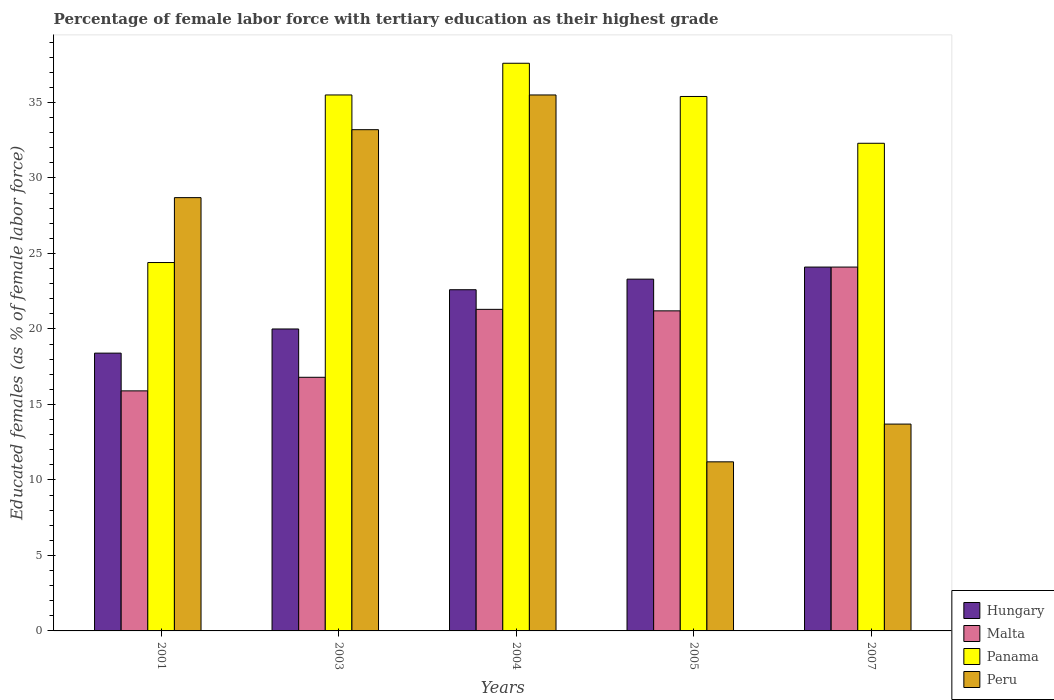How many different coloured bars are there?
Offer a very short reply. 4. How many bars are there on the 4th tick from the left?
Make the answer very short. 4. How many bars are there on the 3rd tick from the right?
Provide a succinct answer. 4. What is the label of the 2nd group of bars from the left?
Your answer should be very brief. 2003. In how many cases, is the number of bars for a given year not equal to the number of legend labels?
Offer a very short reply. 0. What is the percentage of female labor force with tertiary education in Malta in 2003?
Ensure brevity in your answer.  16.8. Across all years, what is the maximum percentage of female labor force with tertiary education in Hungary?
Make the answer very short. 24.1. Across all years, what is the minimum percentage of female labor force with tertiary education in Panama?
Ensure brevity in your answer.  24.4. In which year was the percentage of female labor force with tertiary education in Hungary minimum?
Provide a short and direct response. 2001. What is the total percentage of female labor force with tertiary education in Peru in the graph?
Your answer should be compact. 122.3. What is the difference between the percentage of female labor force with tertiary education in Hungary in 2004 and that in 2005?
Provide a succinct answer. -0.7. What is the difference between the percentage of female labor force with tertiary education in Peru in 2003 and the percentage of female labor force with tertiary education in Malta in 2001?
Keep it short and to the point. 17.3. What is the average percentage of female labor force with tertiary education in Peru per year?
Make the answer very short. 24.46. In the year 2004, what is the difference between the percentage of female labor force with tertiary education in Peru and percentage of female labor force with tertiary education in Malta?
Provide a short and direct response. 14.2. In how many years, is the percentage of female labor force with tertiary education in Peru greater than 20 %?
Give a very brief answer. 3. What is the ratio of the percentage of female labor force with tertiary education in Peru in 2003 to that in 2004?
Your response must be concise. 0.94. Is the percentage of female labor force with tertiary education in Malta in 2001 less than that in 2005?
Provide a succinct answer. Yes. Is the difference between the percentage of female labor force with tertiary education in Peru in 2003 and 2007 greater than the difference between the percentage of female labor force with tertiary education in Malta in 2003 and 2007?
Make the answer very short. Yes. What is the difference between the highest and the second highest percentage of female labor force with tertiary education in Panama?
Offer a terse response. 2.1. What is the difference between the highest and the lowest percentage of female labor force with tertiary education in Panama?
Your response must be concise. 13.2. In how many years, is the percentage of female labor force with tertiary education in Panama greater than the average percentage of female labor force with tertiary education in Panama taken over all years?
Make the answer very short. 3. Is the sum of the percentage of female labor force with tertiary education in Panama in 2001 and 2005 greater than the maximum percentage of female labor force with tertiary education in Hungary across all years?
Give a very brief answer. Yes. What does the 1st bar from the left in 2001 represents?
Your answer should be compact. Hungary. What does the 4th bar from the right in 2004 represents?
Your answer should be compact. Hungary. How many bars are there?
Offer a terse response. 20. What is the difference between two consecutive major ticks on the Y-axis?
Make the answer very short. 5. How are the legend labels stacked?
Provide a succinct answer. Vertical. What is the title of the graph?
Keep it short and to the point. Percentage of female labor force with tertiary education as their highest grade. What is the label or title of the Y-axis?
Provide a succinct answer. Educated females (as % of female labor force). What is the Educated females (as % of female labor force) of Hungary in 2001?
Offer a terse response. 18.4. What is the Educated females (as % of female labor force) in Malta in 2001?
Your answer should be compact. 15.9. What is the Educated females (as % of female labor force) of Panama in 2001?
Make the answer very short. 24.4. What is the Educated females (as % of female labor force) of Peru in 2001?
Your answer should be very brief. 28.7. What is the Educated females (as % of female labor force) of Malta in 2003?
Ensure brevity in your answer.  16.8. What is the Educated females (as % of female labor force) of Panama in 2003?
Offer a terse response. 35.5. What is the Educated females (as % of female labor force) of Peru in 2003?
Your response must be concise. 33.2. What is the Educated females (as % of female labor force) of Hungary in 2004?
Provide a succinct answer. 22.6. What is the Educated females (as % of female labor force) in Malta in 2004?
Offer a very short reply. 21.3. What is the Educated females (as % of female labor force) of Panama in 2004?
Your answer should be very brief. 37.6. What is the Educated females (as % of female labor force) in Peru in 2004?
Ensure brevity in your answer.  35.5. What is the Educated females (as % of female labor force) of Hungary in 2005?
Offer a terse response. 23.3. What is the Educated females (as % of female labor force) of Malta in 2005?
Provide a short and direct response. 21.2. What is the Educated females (as % of female labor force) of Panama in 2005?
Make the answer very short. 35.4. What is the Educated females (as % of female labor force) in Peru in 2005?
Your response must be concise. 11.2. What is the Educated females (as % of female labor force) of Hungary in 2007?
Ensure brevity in your answer.  24.1. What is the Educated females (as % of female labor force) in Malta in 2007?
Your answer should be compact. 24.1. What is the Educated females (as % of female labor force) of Panama in 2007?
Offer a terse response. 32.3. What is the Educated females (as % of female labor force) of Peru in 2007?
Provide a short and direct response. 13.7. Across all years, what is the maximum Educated females (as % of female labor force) of Hungary?
Your answer should be compact. 24.1. Across all years, what is the maximum Educated females (as % of female labor force) in Malta?
Ensure brevity in your answer.  24.1. Across all years, what is the maximum Educated females (as % of female labor force) in Panama?
Your response must be concise. 37.6. Across all years, what is the maximum Educated females (as % of female labor force) of Peru?
Your answer should be compact. 35.5. Across all years, what is the minimum Educated females (as % of female labor force) in Hungary?
Provide a succinct answer. 18.4. Across all years, what is the minimum Educated females (as % of female labor force) of Malta?
Your response must be concise. 15.9. Across all years, what is the minimum Educated females (as % of female labor force) in Panama?
Offer a very short reply. 24.4. Across all years, what is the minimum Educated females (as % of female labor force) in Peru?
Ensure brevity in your answer.  11.2. What is the total Educated females (as % of female labor force) in Hungary in the graph?
Make the answer very short. 108.4. What is the total Educated females (as % of female labor force) of Malta in the graph?
Keep it short and to the point. 99.3. What is the total Educated females (as % of female labor force) in Panama in the graph?
Your response must be concise. 165.2. What is the total Educated females (as % of female labor force) in Peru in the graph?
Keep it short and to the point. 122.3. What is the difference between the Educated females (as % of female labor force) of Hungary in 2001 and that in 2003?
Make the answer very short. -1.6. What is the difference between the Educated females (as % of female labor force) in Peru in 2001 and that in 2003?
Your answer should be very brief. -4.5. What is the difference between the Educated females (as % of female labor force) of Hungary in 2001 and that in 2004?
Offer a terse response. -4.2. What is the difference between the Educated females (as % of female labor force) in Panama in 2001 and that in 2004?
Your answer should be very brief. -13.2. What is the difference between the Educated females (as % of female labor force) in Hungary in 2001 and that in 2005?
Make the answer very short. -4.9. What is the difference between the Educated females (as % of female labor force) in Malta in 2001 and that in 2005?
Your response must be concise. -5.3. What is the difference between the Educated females (as % of female labor force) of Hungary in 2003 and that in 2004?
Provide a succinct answer. -2.6. What is the difference between the Educated females (as % of female labor force) of Malta in 2003 and that in 2004?
Make the answer very short. -4.5. What is the difference between the Educated females (as % of female labor force) of Panama in 2003 and that in 2004?
Offer a terse response. -2.1. What is the difference between the Educated females (as % of female labor force) of Hungary in 2003 and that in 2007?
Give a very brief answer. -4.1. What is the difference between the Educated females (as % of female labor force) in Malta in 2003 and that in 2007?
Provide a succinct answer. -7.3. What is the difference between the Educated females (as % of female labor force) of Panama in 2003 and that in 2007?
Offer a very short reply. 3.2. What is the difference between the Educated females (as % of female labor force) of Hungary in 2004 and that in 2005?
Keep it short and to the point. -0.7. What is the difference between the Educated females (as % of female labor force) in Peru in 2004 and that in 2005?
Your answer should be very brief. 24.3. What is the difference between the Educated females (as % of female labor force) of Peru in 2004 and that in 2007?
Ensure brevity in your answer.  21.8. What is the difference between the Educated females (as % of female labor force) of Hungary in 2005 and that in 2007?
Offer a terse response. -0.8. What is the difference between the Educated females (as % of female labor force) in Peru in 2005 and that in 2007?
Provide a succinct answer. -2.5. What is the difference between the Educated females (as % of female labor force) of Hungary in 2001 and the Educated females (as % of female labor force) of Panama in 2003?
Give a very brief answer. -17.1. What is the difference between the Educated females (as % of female labor force) in Hungary in 2001 and the Educated females (as % of female labor force) in Peru in 2003?
Your answer should be compact. -14.8. What is the difference between the Educated females (as % of female labor force) in Malta in 2001 and the Educated females (as % of female labor force) in Panama in 2003?
Ensure brevity in your answer.  -19.6. What is the difference between the Educated females (as % of female labor force) in Malta in 2001 and the Educated females (as % of female labor force) in Peru in 2003?
Your response must be concise. -17.3. What is the difference between the Educated females (as % of female labor force) of Hungary in 2001 and the Educated females (as % of female labor force) of Malta in 2004?
Ensure brevity in your answer.  -2.9. What is the difference between the Educated females (as % of female labor force) of Hungary in 2001 and the Educated females (as % of female labor force) of Panama in 2004?
Your response must be concise. -19.2. What is the difference between the Educated females (as % of female labor force) in Hungary in 2001 and the Educated females (as % of female labor force) in Peru in 2004?
Your answer should be compact. -17.1. What is the difference between the Educated females (as % of female labor force) in Malta in 2001 and the Educated females (as % of female labor force) in Panama in 2004?
Provide a short and direct response. -21.7. What is the difference between the Educated females (as % of female labor force) in Malta in 2001 and the Educated females (as % of female labor force) in Peru in 2004?
Provide a short and direct response. -19.6. What is the difference between the Educated females (as % of female labor force) of Hungary in 2001 and the Educated females (as % of female labor force) of Malta in 2005?
Provide a succinct answer. -2.8. What is the difference between the Educated females (as % of female labor force) of Hungary in 2001 and the Educated females (as % of female labor force) of Peru in 2005?
Offer a very short reply. 7.2. What is the difference between the Educated females (as % of female labor force) in Malta in 2001 and the Educated females (as % of female labor force) in Panama in 2005?
Your response must be concise. -19.5. What is the difference between the Educated females (as % of female labor force) of Malta in 2001 and the Educated females (as % of female labor force) of Peru in 2005?
Your response must be concise. 4.7. What is the difference between the Educated females (as % of female labor force) in Malta in 2001 and the Educated females (as % of female labor force) in Panama in 2007?
Make the answer very short. -16.4. What is the difference between the Educated females (as % of female labor force) in Panama in 2001 and the Educated females (as % of female labor force) in Peru in 2007?
Provide a short and direct response. 10.7. What is the difference between the Educated females (as % of female labor force) of Hungary in 2003 and the Educated females (as % of female labor force) of Panama in 2004?
Keep it short and to the point. -17.6. What is the difference between the Educated females (as % of female labor force) in Hungary in 2003 and the Educated females (as % of female labor force) in Peru in 2004?
Your response must be concise. -15.5. What is the difference between the Educated females (as % of female labor force) of Malta in 2003 and the Educated females (as % of female labor force) of Panama in 2004?
Ensure brevity in your answer.  -20.8. What is the difference between the Educated females (as % of female labor force) of Malta in 2003 and the Educated females (as % of female labor force) of Peru in 2004?
Your response must be concise. -18.7. What is the difference between the Educated females (as % of female labor force) of Panama in 2003 and the Educated females (as % of female labor force) of Peru in 2004?
Offer a very short reply. 0. What is the difference between the Educated females (as % of female labor force) in Hungary in 2003 and the Educated females (as % of female labor force) in Panama in 2005?
Your answer should be compact. -15.4. What is the difference between the Educated females (as % of female labor force) in Hungary in 2003 and the Educated females (as % of female labor force) in Peru in 2005?
Keep it short and to the point. 8.8. What is the difference between the Educated females (as % of female labor force) in Malta in 2003 and the Educated females (as % of female labor force) in Panama in 2005?
Provide a short and direct response. -18.6. What is the difference between the Educated females (as % of female labor force) of Panama in 2003 and the Educated females (as % of female labor force) of Peru in 2005?
Provide a succinct answer. 24.3. What is the difference between the Educated females (as % of female labor force) of Hungary in 2003 and the Educated females (as % of female labor force) of Malta in 2007?
Ensure brevity in your answer.  -4.1. What is the difference between the Educated females (as % of female labor force) of Hungary in 2003 and the Educated females (as % of female labor force) of Panama in 2007?
Offer a terse response. -12.3. What is the difference between the Educated females (as % of female labor force) in Hungary in 2003 and the Educated females (as % of female labor force) in Peru in 2007?
Your answer should be compact. 6.3. What is the difference between the Educated females (as % of female labor force) in Malta in 2003 and the Educated females (as % of female labor force) in Panama in 2007?
Make the answer very short. -15.5. What is the difference between the Educated females (as % of female labor force) in Panama in 2003 and the Educated females (as % of female labor force) in Peru in 2007?
Provide a short and direct response. 21.8. What is the difference between the Educated females (as % of female labor force) of Hungary in 2004 and the Educated females (as % of female labor force) of Malta in 2005?
Your response must be concise. 1.4. What is the difference between the Educated females (as % of female labor force) in Malta in 2004 and the Educated females (as % of female labor force) in Panama in 2005?
Ensure brevity in your answer.  -14.1. What is the difference between the Educated females (as % of female labor force) of Malta in 2004 and the Educated females (as % of female labor force) of Peru in 2005?
Your answer should be compact. 10.1. What is the difference between the Educated females (as % of female labor force) of Panama in 2004 and the Educated females (as % of female labor force) of Peru in 2005?
Provide a succinct answer. 26.4. What is the difference between the Educated females (as % of female labor force) of Hungary in 2004 and the Educated females (as % of female labor force) of Peru in 2007?
Your response must be concise. 8.9. What is the difference between the Educated females (as % of female labor force) of Malta in 2004 and the Educated females (as % of female labor force) of Panama in 2007?
Your answer should be very brief. -11. What is the difference between the Educated females (as % of female labor force) in Panama in 2004 and the Educated females (as % of female labor force) in Peru in 2007?
Your response must be concise. 23.9. What is the difference between the Educated females (as % of female labor force) in Hungary in 2005 and the Educated females (as % of female labor force) in Panama in 2007?
Make the answer very short. -9. What is the difference between the Educated females (as % of female labor force) in Hungary in 2005 and the Educated females (as % of female labor force) in Peru in 2007?
Your response must be concise. 9.6. What is the difference between the Educated females (as % of female labor force) of Malta in 2005 and the Educated females (as % of female labor force) of Peru in 2007?
Keep it short and to the point. 7.5. What is the difference between the Educated females (as % of female labor force) of Panama in 2005 and the Educated females (as % of female labor force) of Peru in 2007?
Your answer should be compact. 21.7. What is the average Educated females (as % of female labor force) in Hungary per year?
Offer a very short reply. 21.68. What is the average Educated females (as % of female labor force) of Malta per year?
Keep it short and to the point. 19.86. What is the average Educated females (as % of female labor force) in Panama per year?
Your answer should be very brief. 33.04. What is the average Educated females (as % of female labor force) in Peru per year?
Keep it short and to the point. 24.46. In the year 2001, what is the difference between the Educated females (as % of female labor force) in Hungary and Educated females (as % of female labor force) in Panama?
Your answer should be compact. -6. In the year 2001, what is the difference between the Educated females (as % of female labor force) of Malta and Educated females (as % of female labor force) of Panama?
Give a very brief answer. -8.5. In the year 2003, what is the difference between the Educated females (as % of female labor force) in Hungary and Educated females (as % of female labor force) in Panama?
Provide a short and direct response. -15.5. In the year 2003, what is the difference between the Educated females (as % of female labor force) of Malta and Educated females (as % of female labor force) of Panama?
Provide a succinct answer. -18.7. In the year 2003, what is the difference between the Educated females (as % of female labor force) of Malta and Educated females (as % of female labor force) of Peru?
Offer a terse response. -16.4. In the year 2004, what is the difference between the Educated females (as % of female labor force) in Hungary and Educated females (as % of female labor force) in Panama?
Make the answer very short. -15. In the year 2004, what is the difference between the Educated females (as % of female labor force) in Hungary and Educated females (as % of female labor force) in Peru?
Offer a very short reply. -12.9. In the year 2004, what is the difference between the Educated females (as % of female labor force) of Malta and Educated females (as % of female labor force) of Panama?
Give a very brief answer. -16.3. In the year 2004, what is the difference between the Educated females (as % of female labor force) in Malta and Educated females (as % of female labor force) in Peru?
Your response must be concise. -14.2. In the year 2005, what is the difference between the Educated females (as % of female labor force) in Hungary and Educated females (as % of female labor force) in Peru?
Offer a terse response. 12.1. In the year 2005, what is the difference between the Educated females (as % of female labor force) of Panama and Educated females (as % of female labor force) of Peru?
Provide a succinct answer. 24.2. In the year 2007, what is the difference between the Educated females (as % of female labor force) in Hungary and Educated females (as % of female labor force) in Malta?
Ensure brevity in your answer.  0. In the year 2007, what is the difference between the Educated females (as % of female labor force) in Hungary and Educated females (as % of female labor force) in Panama?
Keep it short and to the point. -8.2. In the year 2007, what is the difference between the Educated females (as % of female labor force) in Malta and Educated females (as % of female labor force) in Panama?
Ensure brevity in your answer.  -8.2. What is the ratio of the Educated females (as % of female labor force) in Hungary in 2001 to that in 2003?
Your response must be concise. 0.92. What is the ratio of the Educated females (as % of female labor force) of Malta in 2001 to that in 2003?
Your response must be concise. 0.95. What is the ratio of the Educated females (as % of female labor force) of Panama in 2001 to that in 2003?
Keep it short and to the point. 0.69. What is the ratio of the Educated females (as % of female labor force) of Peru in 2001 to that in 2003?
Make the answer very short. 0.86. What is the ratio of the Educated females (as % of female labor force) of Hungary in 2001 to that in 2004?
Your answer should be very brief. 0.81. What is the ratio of the Educated females (as % of female labor force) in Malta in 2001 to that in 2004?
Provide a short and direct response. 0.75. What is the ratio of the Educated females (as % of female labor force) in Panama in 2001 to that in 2004?
Make the answer very short. 0.65. What is the ratio of the Educated females (as % of female labor force) in Peru in 2001 to that in 2004?
Offer a terse response. 0.81. What is the ratio of the Educated females (as % of female labor force) of Hungary in 2001 to that in 2005?
Your answer should be very brief. 0.79. What is the ratio of the Educated females (as % of female labor force) in Panama in 2001 to that in 2005?
Your answer should be very brief. 0.69. What is the ratio of the Educated females (as % of female labor force) in Peru in 2001 to that in 2005?
Keep it short and to the point. 2.56. What is the ratio of the Educated females (as % of female labor force) of Hungary in 2001 to that in 2007?
Your response must be concise. 0.76. What is the ratio of the Educated females (as % of female labor force) in Malta in 2001 to that in 2007?
Provide a succinct answer. 0.66. What is the ratio of the Educated females (as % of female labor force) in Panama in 2001 to that in 2007?
Give a very brief answer. 0.76. What is the ratio of the Educated females (as % of female labor force) of Peru in 2001 to that in 2007?
Provide a short and direct response. 2.09. What is the ratio of the Educated females (as % of female labor force) of Hungary in 2003 to that in 2004?
Give a very brief answer. 0.89. What is the ratio of the Educated females (as % of female labor force) in Malta in 2003 to that in 2004?
Make the answer very short. 0.79. What is the ratio of the Educated females (as % of female labor force) in Panama in 2003 to that in 2004?
Provide a succinct answer. 0.94. What is the ratio of the Educated females (as % of female labor force) of Peru in 2003 to that in 2004?
Your answer should be very brief. 0.94. What is the ratio of the Educated females (as % of female labor force) of Hungary in 2003 to that in 2005?
Your answer should be compact. 0.86. What is the ratio of the Educated females (as % of female labor force) in Malta in 2003 to that in 2005?
Keep it short and to the point. 0.79. What is the ratio of the Educated females (as % of female labor force) of Peru in 2003 to that in 2005?
Give a very brief answer. 2.96. What is the ratio of the Educated females (as % of female labor force) of Hungary in 2003 to that in 2007?
Keep it short and to the point. 0.83. What is the ratio of the Educated females (as % of female labor force) of Malta in 2003 to that in 2007?
Offer a terse response. 0.7. What is the ratio of the Educated females (as % of female labor force) in Panama in 2003 to that in 2007?
Ensure brevity in your answer.  1.1. What is the ratio of the Educated females (as % of female labor force) in Peru in 2003 to that in 2007?
Offer a very short reply. 2.42. What is the ratio of the Educated females (as % of female labor force) in Hungary in 2004 to that in 2005?
Offer a terse response. 0.97. What is the ratio of the Educated females (as % of female labor force) in Malta in 2004 to that in 2005?
Your answer should be very brief. 1. What is the ratio of the Educated females (as % of female labor force) in Panama in 2004 to that in 2005?
Your response must be concise. 1.06. What is the ratio of the Educated females (as % of female labor force) of Peru in 2004 to that in 2005?
Keep it short and to the point. 3.17. What is the ratio of the Educated females (as % of female labor force) in Hungary in 2004 to that in 2007?
Your response must be concise. 0.94. What is the ratio of the Educated females (as % of female labor force) of Malta in 2004 to that in 2007?
Give a very brief answer. 0.88. What is the ratio of the Educated females (as % of female labor force) in Panama in 2004 to that in 2007?
Ensure brevity in your answer.  1.16. What is the ratio of the Educated females (as % of female labor force) of Peru in 2004 to that in 2007?
Make the answer very short. 2.59. What is the ratio of the Educated females (as % of female labor force) in Hungary in 2005 to that in 2007?
Your answer should be compact. 0.97. What is the ratio of the Educated females (as % of female labor force) of Malta in 2005 to that in 2007?
Provide a short and direct response. 0.88. What is the ratio of the Educated females (as % of female labor force) of Panama in 2005 to that in 2007?
Make the answer very short. 1.1. What is the ratio of the Educated females (as % of female labor force) of Peru in 2005 to that in 2007?
Your response must be concise. 0.82. What is the difference between the highest and the second highest Educated females (as % of female labor force) in Hungary?
Provide a succinct answer. 0.8. What is the difference between the highest and the second highest Educated females (as % of female labor force) in Malta?
Your answer should be compact. 2.8. What is the difference between the highest and the lowest Educated females (as % of female labor force) in Hungary?
Provide a succinct answer. 5.7. What is the difference between the highest and the lowest Educated females (as % of female labor force) in Peru?
Your answer should be very brief. 24.3. 